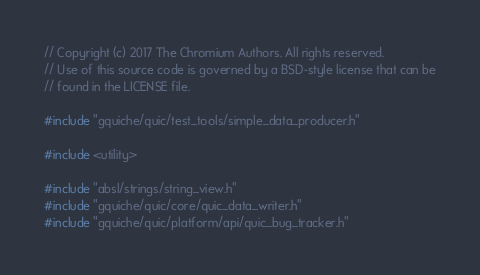Convert code to text. <code><loc_0><loc_0><loc_500><loc_500><_C++_>// Copyright (c) 2017 The Chromium Authors. All rights reserved.
// Use of this source code is governed by a BSD-style license that can be
// found in the LICENSE file.

#include "gquiche/quic/test_tools/simple_data_producer.h"

#include <utility>

#include "absl/strings/string_view.h"
#include "gquiche/quic/core/quic_data_writer.h"
#include "gquiche/quic/platform/api/quic_bug_tracker.h"</code> 